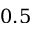Convert formula to latex. <formula><loc_0><loc_0><loc_500><loc_500>0 . 5</formula> 